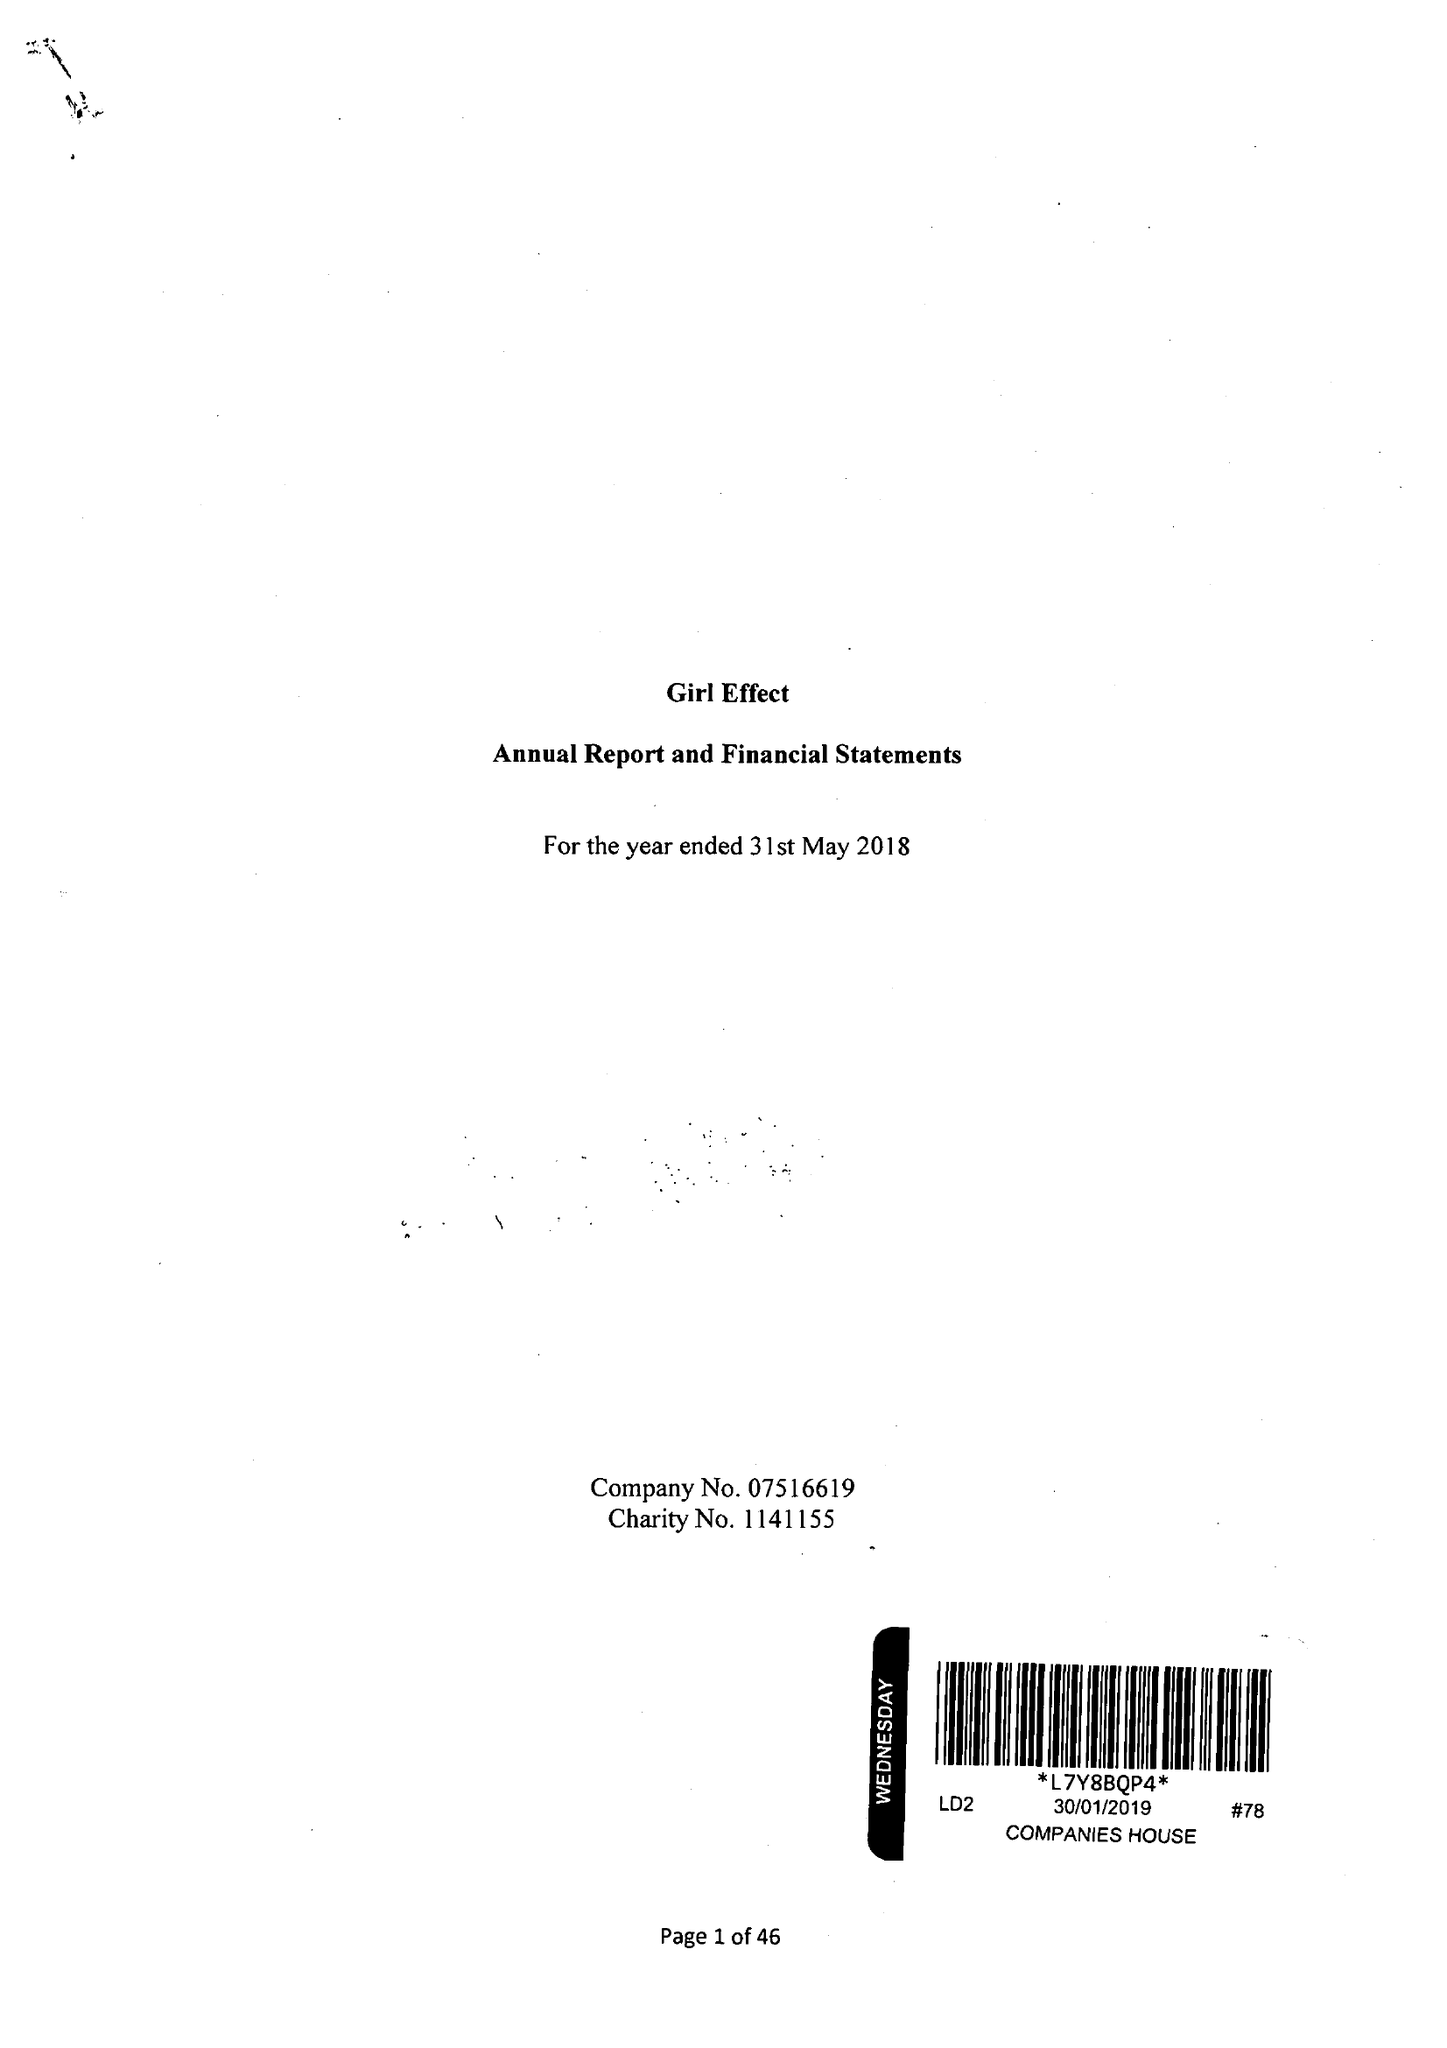What is the value for the charity_number?
Answer the question using a single word or phrase. 1141155 